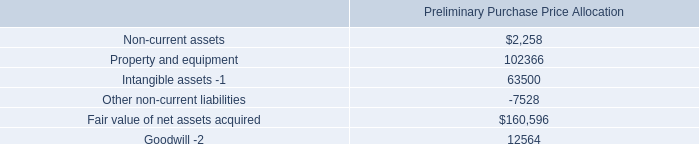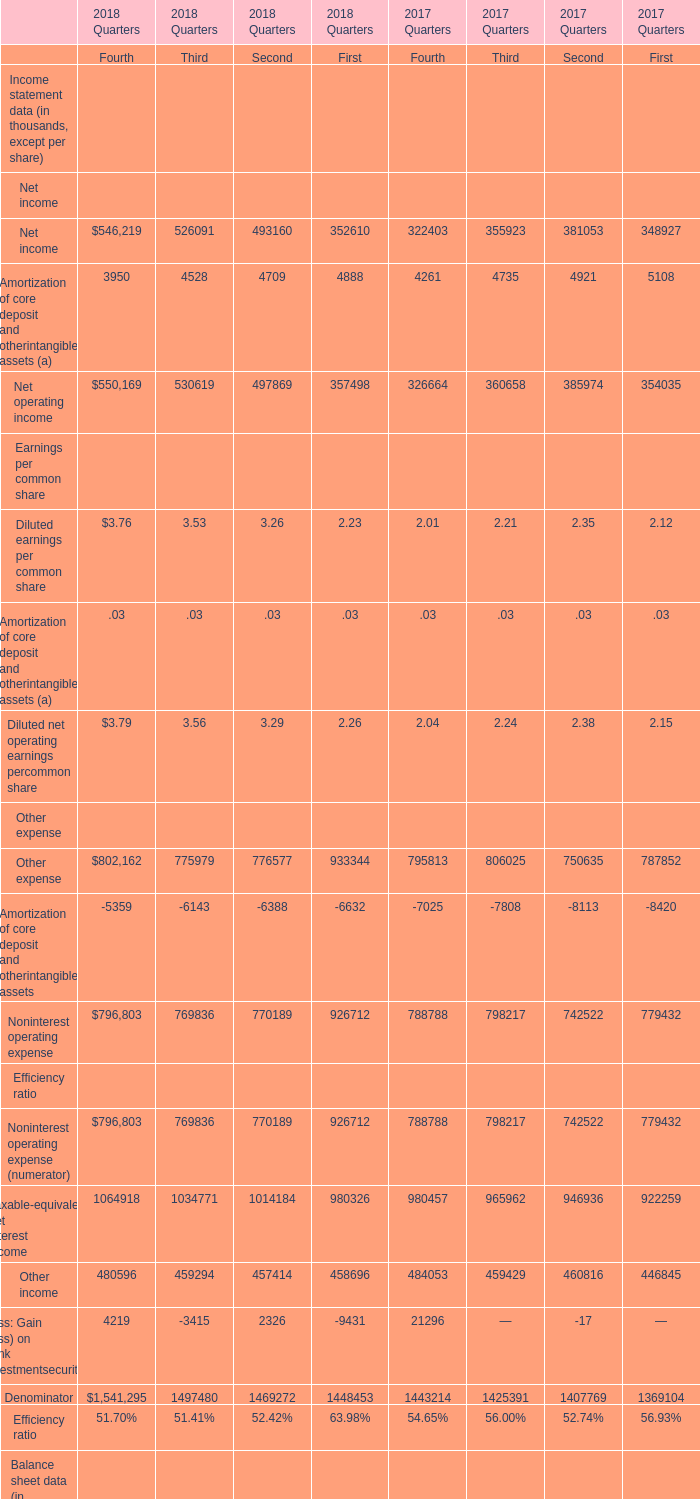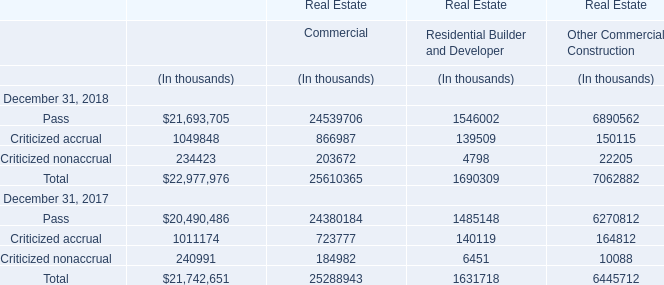for the mtn group acquisition , what was the cost per tower ? . 
Computations: ((173.2 * 1000000) / 962)
Answer: 180041.58004. 